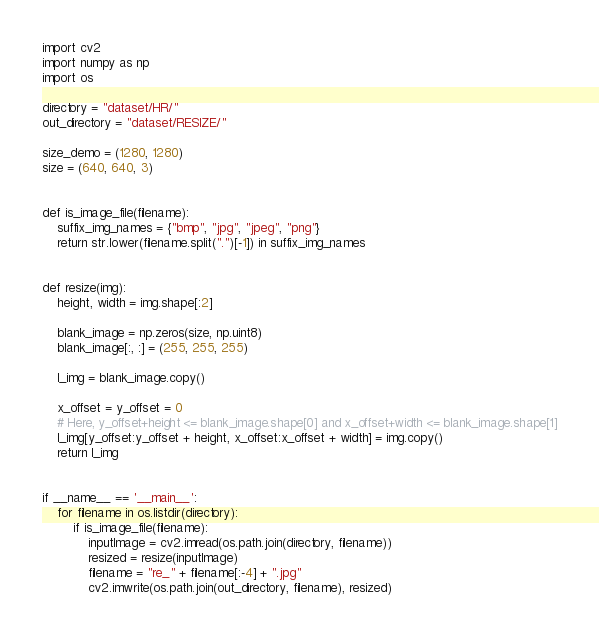<code> <loc_0><loc_0><loc_500><loc_500><_Python_>import cv2
import numpy as np
import os

directory = "dataset/HR/"
out_directory = "dataset/RESIZE/"

size_demo = (1280, 1280)
size = (640, 640, 3)


def is_image_file(filename):
    suffix_img_names = {"bmp", "jpg", "jpeg", "png"}
    return str.lower(filename.split(".")[-1]) in suffix_img_names


def resize(img):
    height, width = img.shape[:2]

    blank_image = np.zeros(size, np.uint8)
    blank_image[:, :] = (255, 255, 255)

    l_img = blank_image.copy()

    x_offset = y_offset = 0
    # Here, y_offset+height <= blank_image.shape[0] and x_offset+width <= blank_image.shape[1]
    l_img[y_offset:y_offset + height, x_offset:x_offset + width] = img.copy()
    return l_img


if __name__ == '__main__':
    for filename in os.listdir(directory):
        if is_image_file(filename):
            inputImage = cv2.imread(os.path.join(directory, filename))
            resized = resize(inputImage)
            filename = "re_" + filename[:-4] + ".jpg"
            cv2.imwrite(os.path.join(out_directory, filename), resized)
</code> 